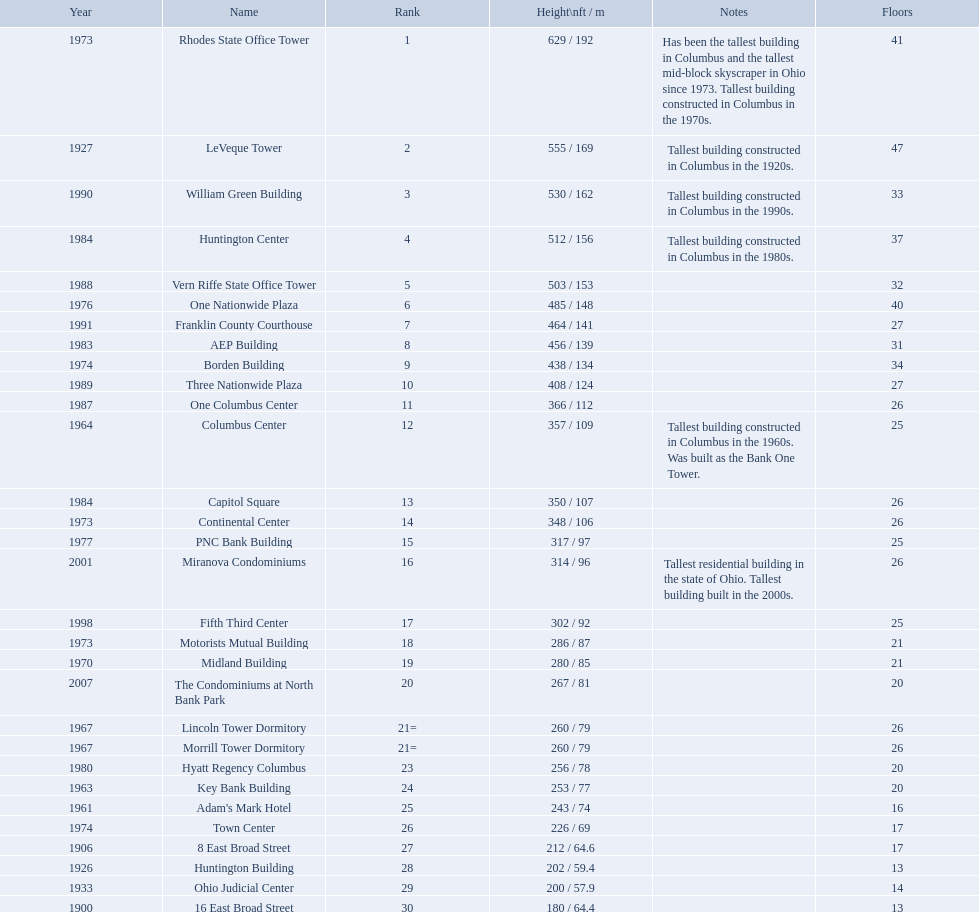What are the heights of all the buildings 629 / 192, 555 / 169, 530 / 162, 512 / 156, 503 / 153, 485 / 148, 464 / 141, 456 / 139, 438 / 134, 408 / 124, 366 / 112, 357 / 109, 350 / 107, 348 / 106, 317 / 97, 314 / 96, 302 / 92, 286 / 87, 280 / 85, 267 / 81, 260 / 79, 260 / 79, 256 / 78, 253 / 77, 243 / 74, 226 / 69, 212 / 64.6, 202 / 59.4, 200 / 57.9, 180 / 64.4. What are the heights of the aep and columbus center buildings 456 / 139, 357 / 109. Which height is greater? 456 / 139. What building is this for? AEP Building. 